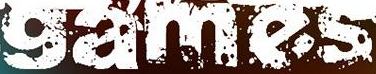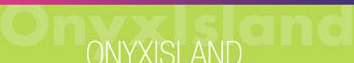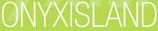What words are shown in these images in order, separated by a semicolon? games; Onyxlsland; ONYXISLAND 